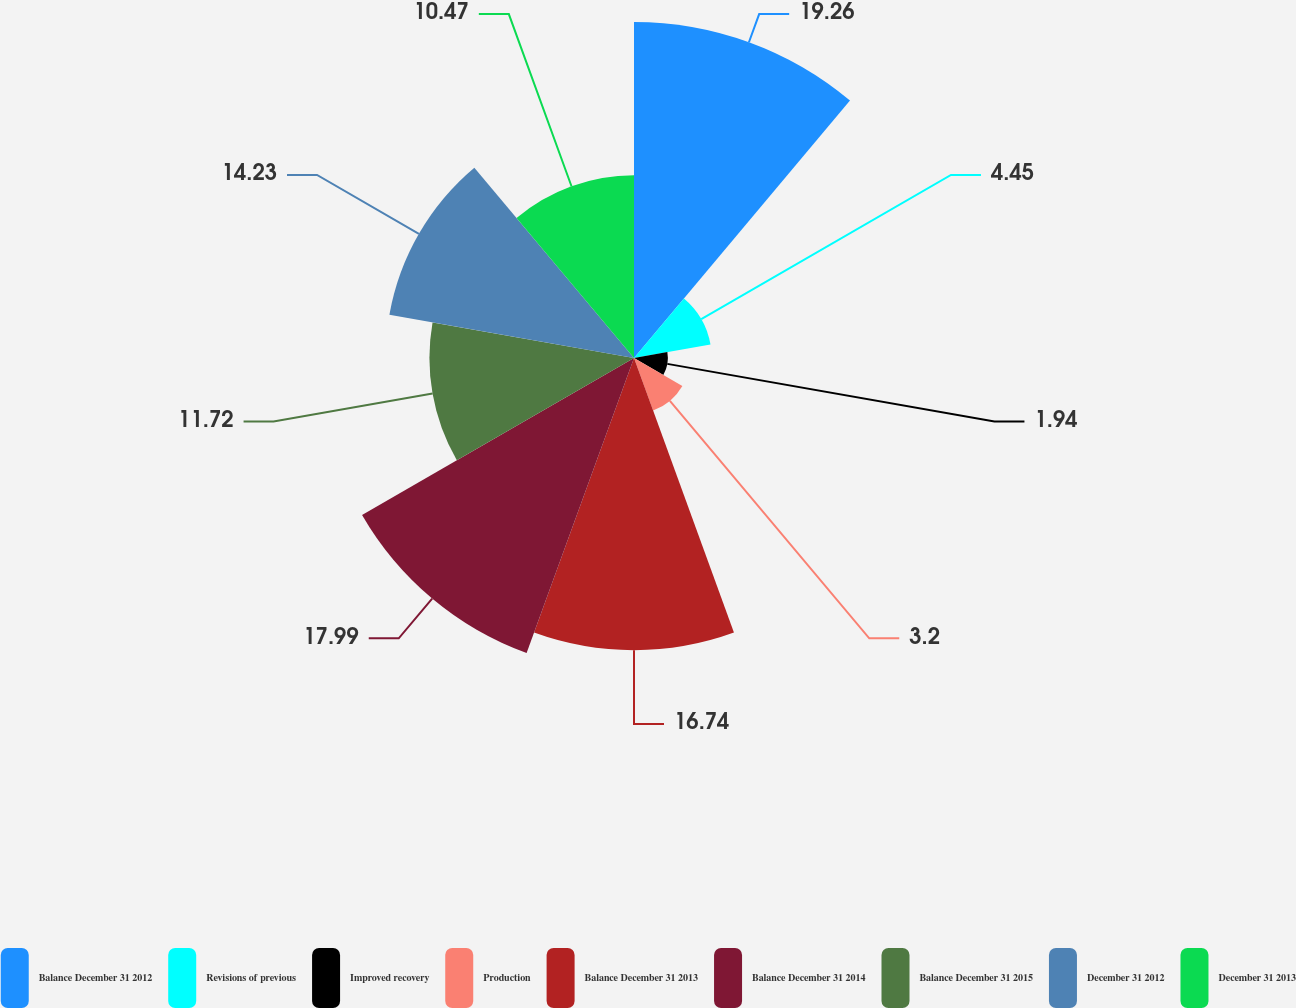Convert chart to OTSL. <chart><loc_0><loc_0><loc_500><loc_500><pie_chart><fcel>Balance December 31 2012<fcel>Revisions of previous<fcel>Improved recovery<fcel>Production<fcel>Balance December 31 2013<fcel>Balance December 31 2014<fcel>Balance December 31 2015<fcel>December 31 2012<fcel>December 31 2013<nl><fcel>19.25%<fcel>4.45%<fcel>1.94%<fcel>3.2%<fcel>16.74%<fcel>17.99%<fcel>11.72%<fcel>14.23%<fcel>10.47%<nl></chart> 